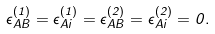<formula> <loc_0><loc_0><loc_500><loc_500>\epsilon ^ { ( 1 ) } _ { A B } = \epsilon ^ { ( 1 ) } _ { A i } = \epsilon ^ { ( 2 ) } _ { A B } = \epsilon ^ { ( 2 ) } _ { A i } = 0 .</formula> 